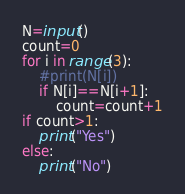Convert code to text. <code><loc_0><loc_0><loc_500><loc_500><_Python_>N=input()
count=0
for i in range(3):
    #print(N[i])
    if N[i]==N[i+1]:
        count=count+1
if count>1:
    print("Yes")
else:
    print("No")</code> 